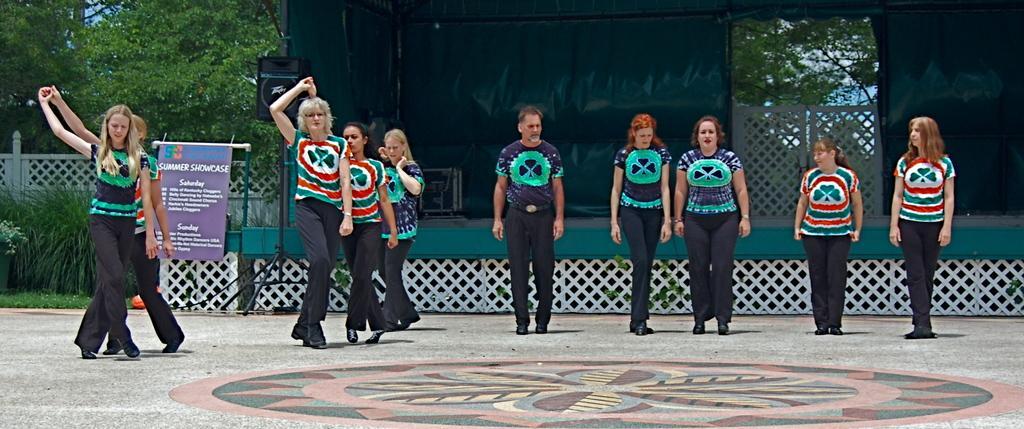Describe this image in one or two sentences. In this image, we can see persons in front of the stage. There is a speaker and banner in the middle of the image. There are some trees and plants on the left side of the image. 